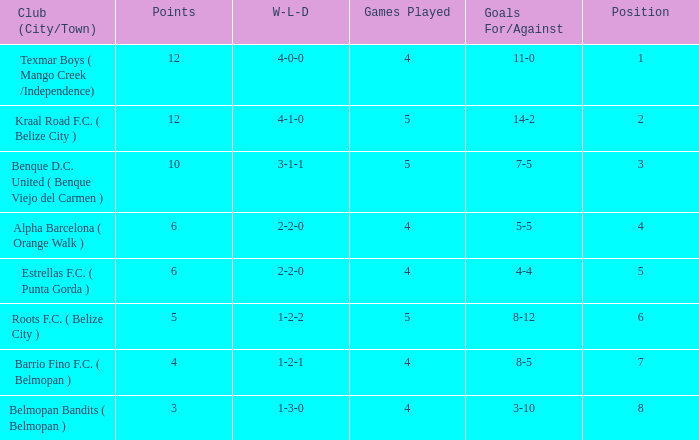What's the w-l-d with position being 1 4-0-0. 